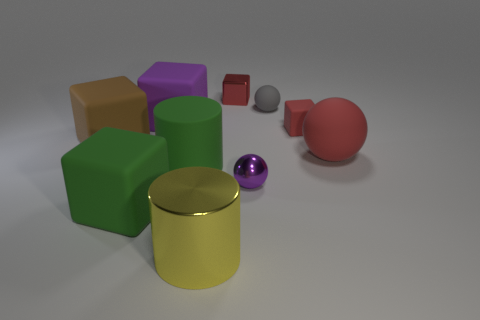Subtract 1 blocks. How many blocks are left? 4 Subtract all tiny shiny blocks. How many blocks are left? 4 Subtract all green cubes. How many cubes are left? 4 Subtract all cyan spheres. Subtract all brown blocks. How many spheres are left? 3 Subtract all spheres. How many objects are left? 7 Add 9 yellow cylinders. How many yellow cylinders exist? 10 Subtract 1 red balls. How many objects are left? 9 Subtract all small gray spheres. Subtract all tiny rubber things. How many objects are left? 7 Add 8 brown rubber cubes. How many brown rubber cubes are left? 9 